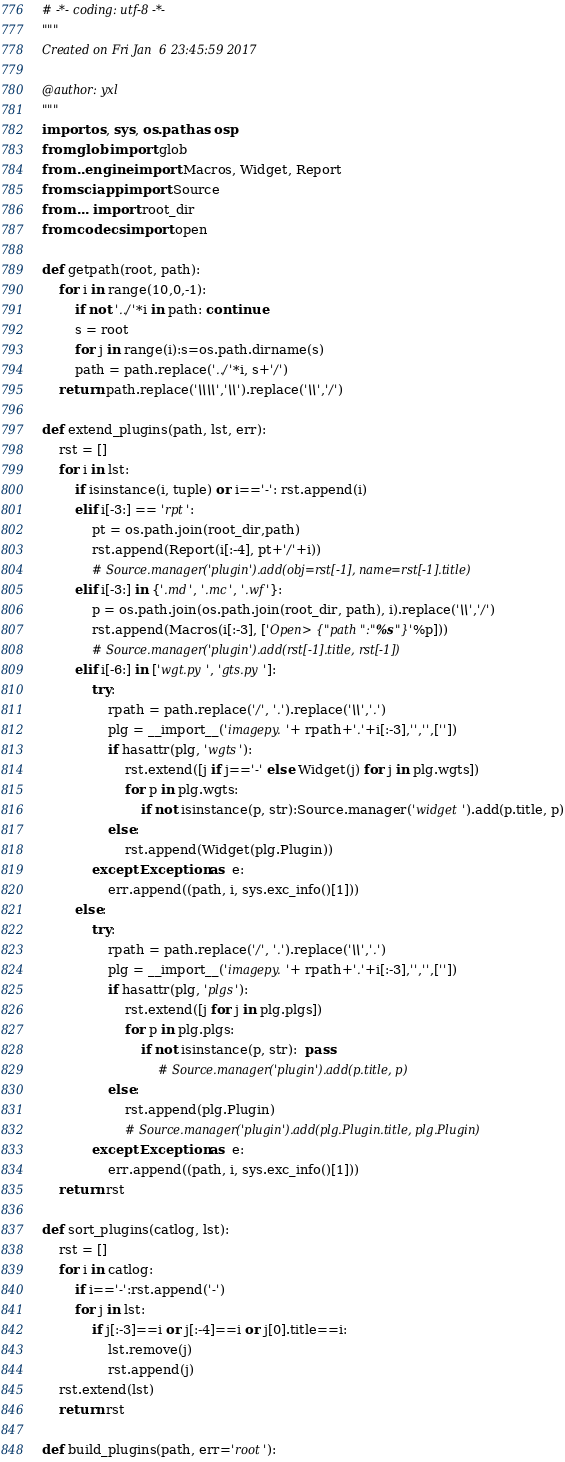Convert code to text. <code><loc_0><loc_0><loc_500><loc_500><_Python_># -*- coding: utf-8 -*-
"""
Created on Fri Jan  6 23:45:59 2017

@author: yxl
"""
import os, sys, os.path as osp
from glob import glob
from ..engine import Macros, Widget, Report
from sciapp import Source
from ... import root_dir
from codecs import open

def getpath(root, path):
    for i in range(10,0,-1):
        if not '../'*i in path: continue
        s = root
        for j in range(i):s=os.path.dirname(s)
        path = path.replace('../'*i, s+'/')
    return path.replace('\\\\','\\').replace('\\','/')

def extend_plugins(path, lst, err):
    rst = []
    for i in lst:
        if isinstance(i, tuple) or i=='-': rst.append(i)
        elif i[-3:] == 'rpt':
            pt = os.path.join(root_dir,path)
            rst.append(Report(i[:-4], pt+'/'+i))
            # Source.manager('plugin').add(obj=rst[-1], name=rst[-1].title)
        elif i[-3:] in {'.md', '.mc', '.wf'}:
            p = os.path.join(os.path.join(root_dir, path), i).replace('\\','/')
            rst.append(Macros(i[:-3], ['Open>{"path":"%s"}'%p]))
            # Source.manager('plugin').add(rst[-1].title, rst[-1])
        elif i[-6:] in ['wgt.py', 'gts.py']:
            try:
                rpath = path.replace('/', '.').replace('\\','.')
                plg = __import__('imagepy.'+ rpath+'.'+i[:-3],'','',[''])
                if hasattr(plg, 'wgts'):
                    rst.extend([j if j=='-' else Widget(j) for j in plg.wgts])
                    for p in plg.wgts:
                        if not isinstance(p, str):Source.manager('widget').add(p.title, p)
                else: 
                    rst.append(Widget(plg.Plugin))
            except Exception as  e:
                err.append((path, i, sys.exc_info()[1]))
        else:
            try:
                rpath = path.replace('/', '.').replace('\\','.')
                plg = __import__('imagepy.'+ rpath+'.'+i[:-3],'','',[''])
                if hasattr(plg, 'plgs'):
                    rst.extend([j for j in plg.plgs])
                    for p in plg.plgs:
                        if not isinstance(p, str):  pass
                            # Source.manager('plugin').add(p.title, p)
                else: 
                    rst.append(plg.Plugin)
                    # Source.manager('plugin').add(plg.Plugin.title, plg.Plugin)
            except Exception as  e:
                err.append((path, i, sys.exc_info()[1]))
    return rst
            
def sort_plugins(catlog, lst):
    rst = []
    for i in catlog:
        if i=='-':rst.append('-')
        for j in lst:
            if j[:-3]==i or j[:-4]==i or j[0].title==i:
                lst.remove(j)
                rst.append(j)
    rst.extend(lst)
    return rst
        
def build_plugins(path, err='root'):</code> 